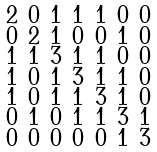<formula> <loc_0><loc_0><loc_500><loc_500>\begin{smallmatrix} 2 & 0 & 1 & 1 & 1 & 0 & 0 \\ 0 & 2 & 1 & 0 & 0 & 1 & 0 \\ 1 & 1 & 3 & 1 & 1 & 0 & 0 \\ 1 & 0 & 1 & 3 & 1 & 1 & 0 \\ 1 & 0 & 1 & 1 & 3 & 1 & 0 \\ 0 & 1 & 0 & 1 & 1 & 3 & 1 \\ 0 & 0 & 0 & 0 & 0 & 1 & 3 \end{smallmatrix}</formula> 